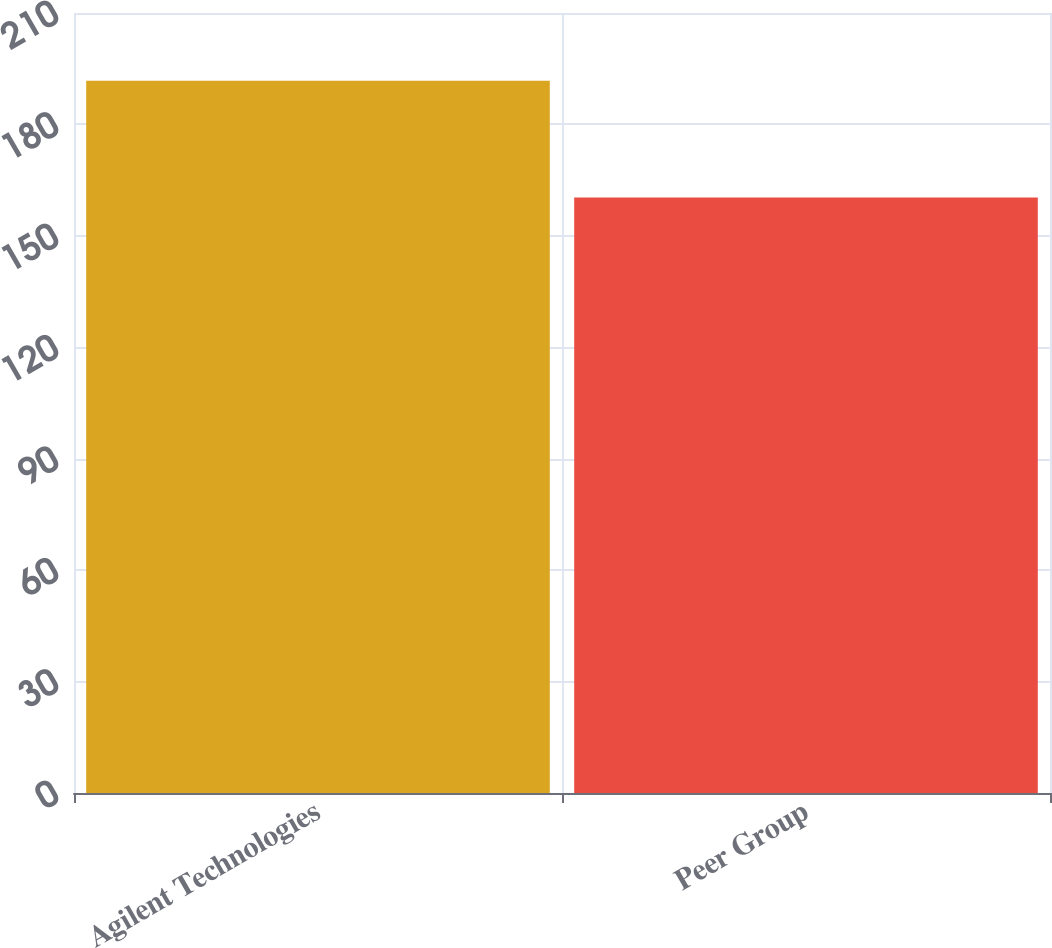<chart> <loc_0><loc_0><loc_500><loc_500><bar_chart><fcel>Agilent Technologies<fcel>Peer Group<nl><fcel>191.77<fcel>160.31<nl></chart> 